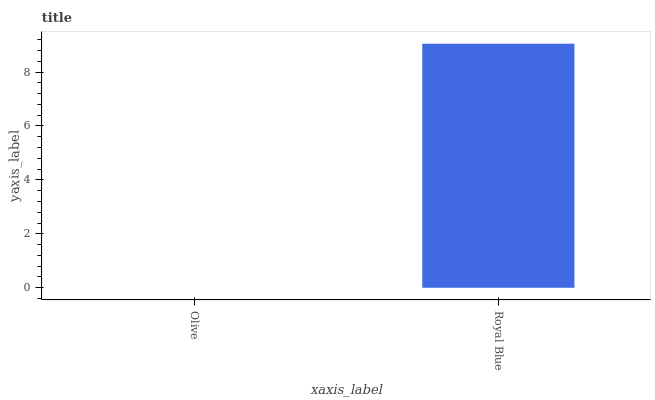Is Olive the minimum?
Answer yes or no. Yes. Is Royal Blue the maximum?
Answer yes or no. Yes. Is Royal Blue the minimum?
Answer yes or no. No. Is Royal Blue greater than Olive?
Answer yes or no. Yes. Is Olive less than Royal Blue?
Answer yes or no. Yes. Is Olive greater than Royal Blue?
Answer yes or no. No. Is Royal Blue less than Olive?
Answer yes or no. No. Is Royal Blue the high median?
Answer yes or no. Yes. Is Olive the low median?
Answer yes or no. Yes. Is Olive the high median?
Answer yes or no. No. Is Royal Blue the low median?
Answer yes or no. No. 